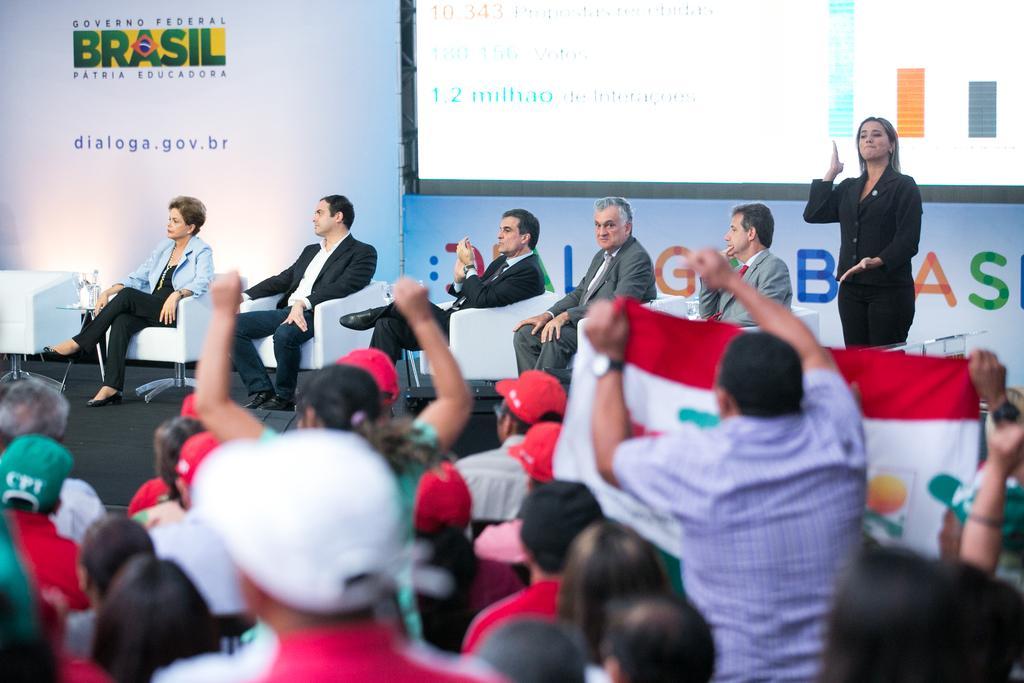Please provide a concise description of this image. In the foreground of the image there are some group of persons siting and some are standing and in the background of the image we can see some group of persons sitting on chairs on stage and there is a lady person standing on stage, there is projector screen and white color sheet. 